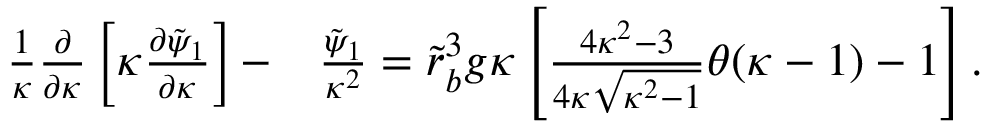<formula> <loc_0><loc_0><loc_500><loc_500>\begin{array} { r l } { \frac { 1 } { \kappa } \frac { \partial } { \partial \kappa } \left [ \kappa \frac { \partial \tilde { \psi } _ { 1 } } { \partial \kappa } \right ] - } & { \frac { \tilde { \psi } _ { 1 } } { \kappa ^ { 2 } } = \tilde { r } _ { b } ^ { 3 } g \kappa \left [ \frac { 4 \kappa ^ { 2 } - 3 } { 4 \kappa \sqrt { \kappa ^ { 2 } - 1 } } \theta ( \kappa - 1 ) - 1 \right ] . } \end{array}</formula> 